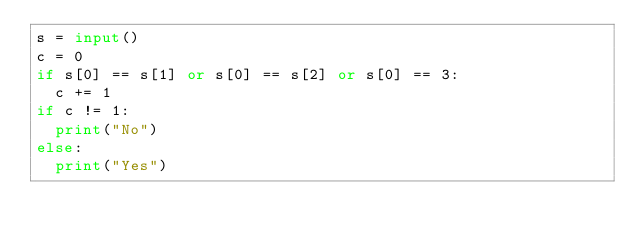<code> <loc_0><loc_0><loc_500><loc_500><_Python_>s = input()
c = 0
if s[0] == s[1] or s[0] == s[2] or s[0] == 3:
  c += 1
if c != 1:
  print("No")
else:
  print("Yes")</code> 